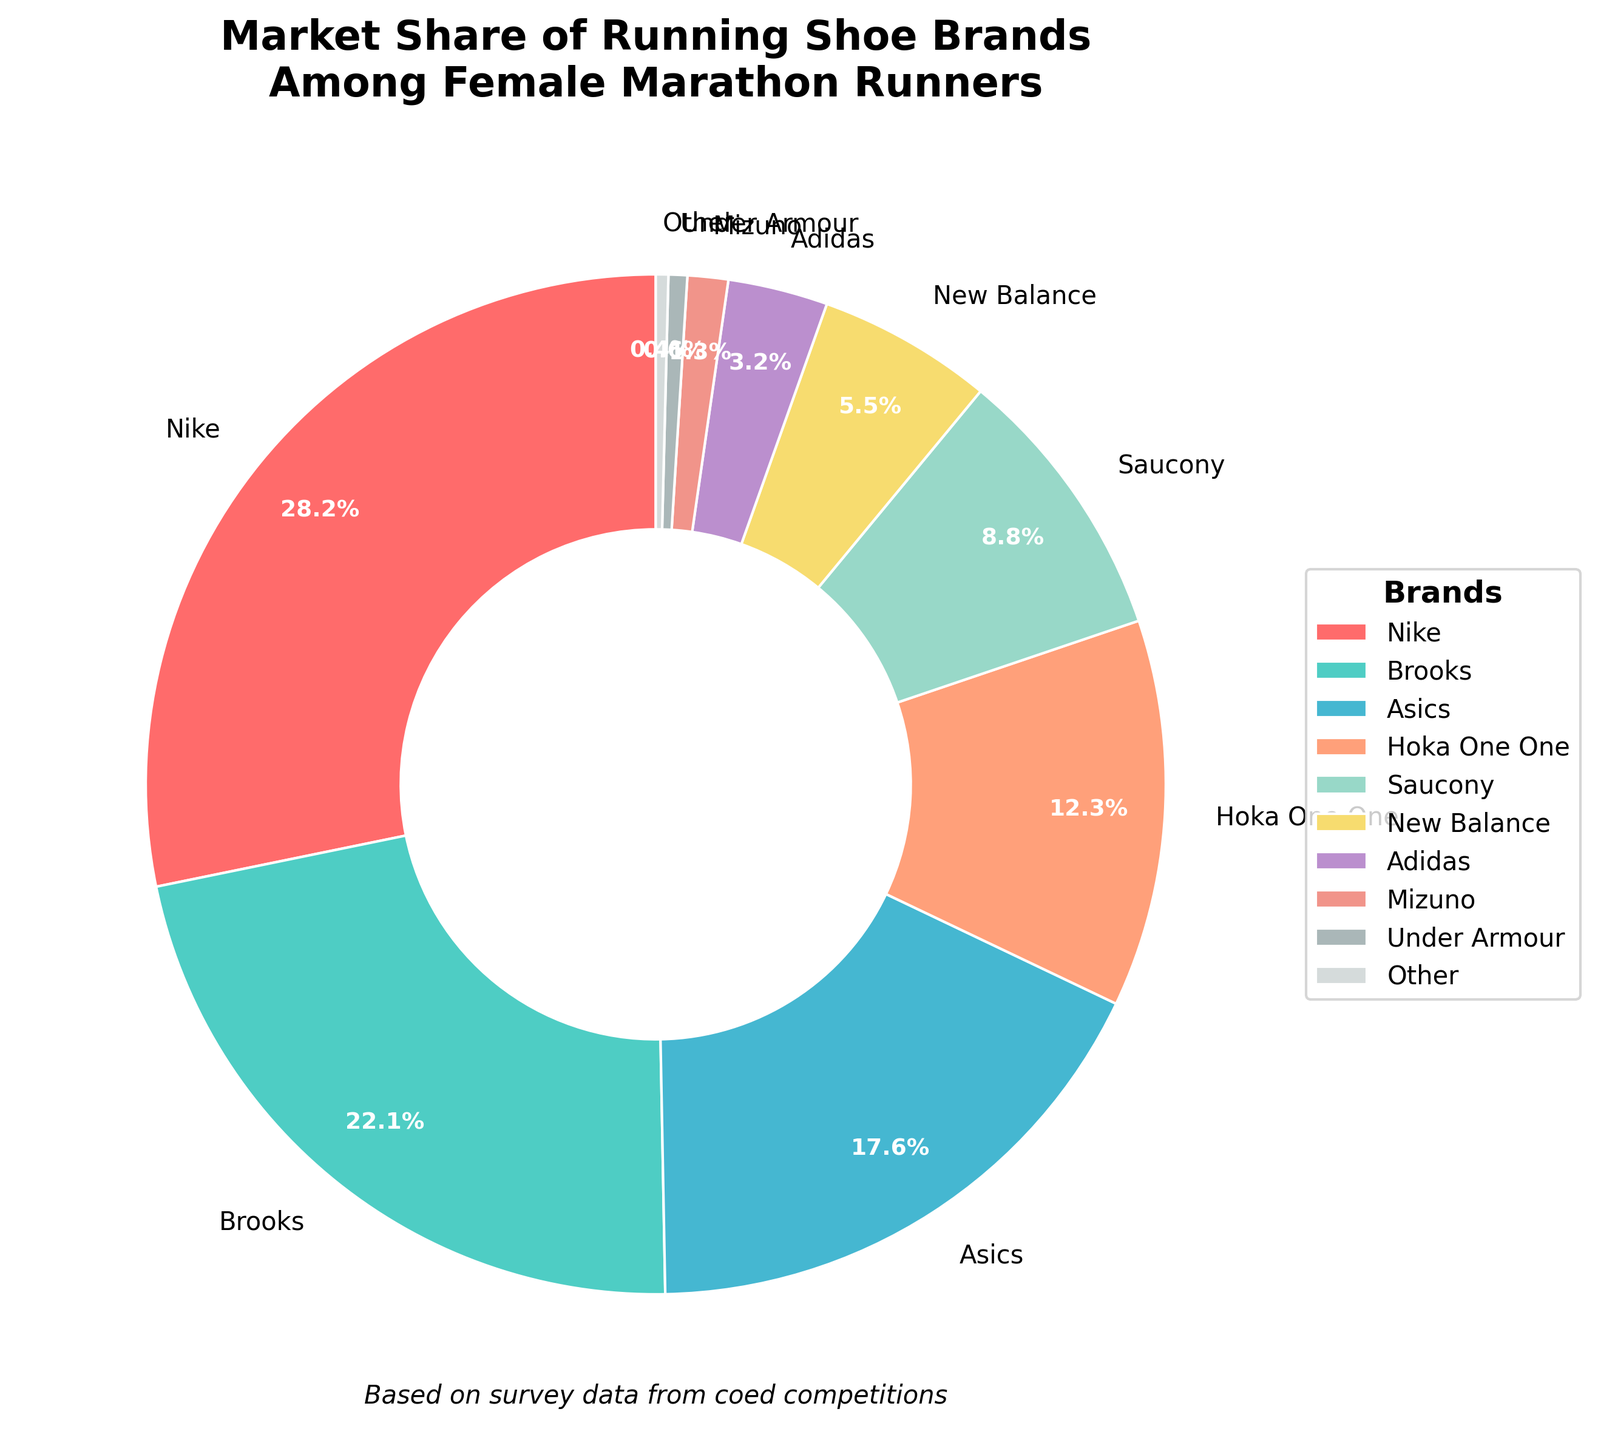Which brand has the highest market share among female marathon runners? By referring to the pie chart, it is evident that Nike has the largest slice of the pie chart. The label shows a market share of 28.5%.
Answer: Nike Which brand has a higher market share, Brooks or Asics? By comparing the slices labeled Brooks and Asics, we find Brooks has a market share of 22.3% and Asics has 17.8%. Therefore, Brooks has a higher market share than Asics.
Answer: Brooks What is the combined market share of Saucony and New Balance? The market share of Saucony is 8.9% and New Balance is 5.6%. Adding these values together: 8.9 + 5.6 = 14.5%.
Answer: 14.5% Which brands have a market share less than 5%? By examining each slice in the pie chart and noting their market shares, the brands with market shares less than 5% are Adidas (3.2%), Mizuno (1.3%), Under Armour (0.6%), and Other (0.4%).
Answer: Adidas, Mizuno, Under Armour, Other Is the market share of Nike more than double that of Hoka One One? Nike's market share is 28.5% and Hoka One One's is 12.4%. Doubling Hoka One One's share gives 2 * 12.4 = 24.8%. Since 28.5% is more than 24.8%, Nike's market share is indeed more than double that of Hoka One One.
Answer: Yes Which brands occupy more than one-fifth of the market share individually? One-fifth of the market share is 20%. Brands with market shares more than 20% are identified by examining the pie chart. Both Nike (28.5%) and Brooks (22.3%) have over 20% market share.
Answer: Nike, Brooks What is the difference in market share between the top two brands? The market share of Nike is 28.5% and Brooks is 22.3%. The difference between these two values is 28.5 - 22.3 = 6.2%.
Answer: 6.2% What is the total market share of all brands? Since it is a complete pie chart, the total market share for all brands must sum to 100%.
Answer: 100% What color represents the New Balance brand in the pie chart? By referring to the color assigned to the New Balance slice on the pie chart, it is represented by a color similar to yellow (since the colors were predefined and the label is easily identified).
Answer: Yellow Which brand holds a smaller market share between Adidas and Mizuno? By comparing the slices labeled Adidas and Mizuno, Adidas has a market share of 3.2% while Mizuno has 1.3%. Therefore, Mizuno holds a smaller market share than Adidas.
Answer: Mizuno 